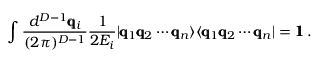Convert formula to latex. <formula><loc_0><loc_0><loc_500><loc_500>\int \frac { d ^ { D - 1 } \pm b { q } _ { i } } { ( 2 \pi ) ^ { D - 1 } } \frac { 1 } { 2 E _ { i } } | \pm b { q } _ { 1 } \pm b { q } _ { 2 } \cdots \pm b { q } _ { n } \rangle \langle \pm b { q } _ { 1 } \pm b { q } _ { 2 } \cdots \pm b { q } _ { n } | = \pm b { 1 } \, .</formula> 